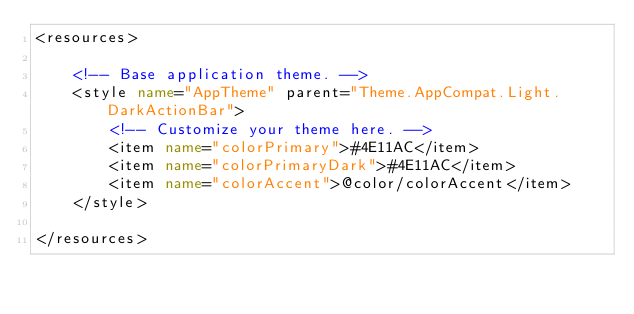<code> <loc_0><loc_0><loc_500><loc_500><_XML_><resources>

    <!-- Base application theme. -->
    <style name="AppTheme" parent="Theme.AppCompat.Light.DarkActionBar">
        <!-- Customize your theme here. -->
        <item name="colorPrimary">#4E11AC</item>
        <item name="colorPrimaryDark">#4E11AC</item>
        <item name="colorAccent">@color/colorAccent</item>
    </style>

</resources>
</code> 